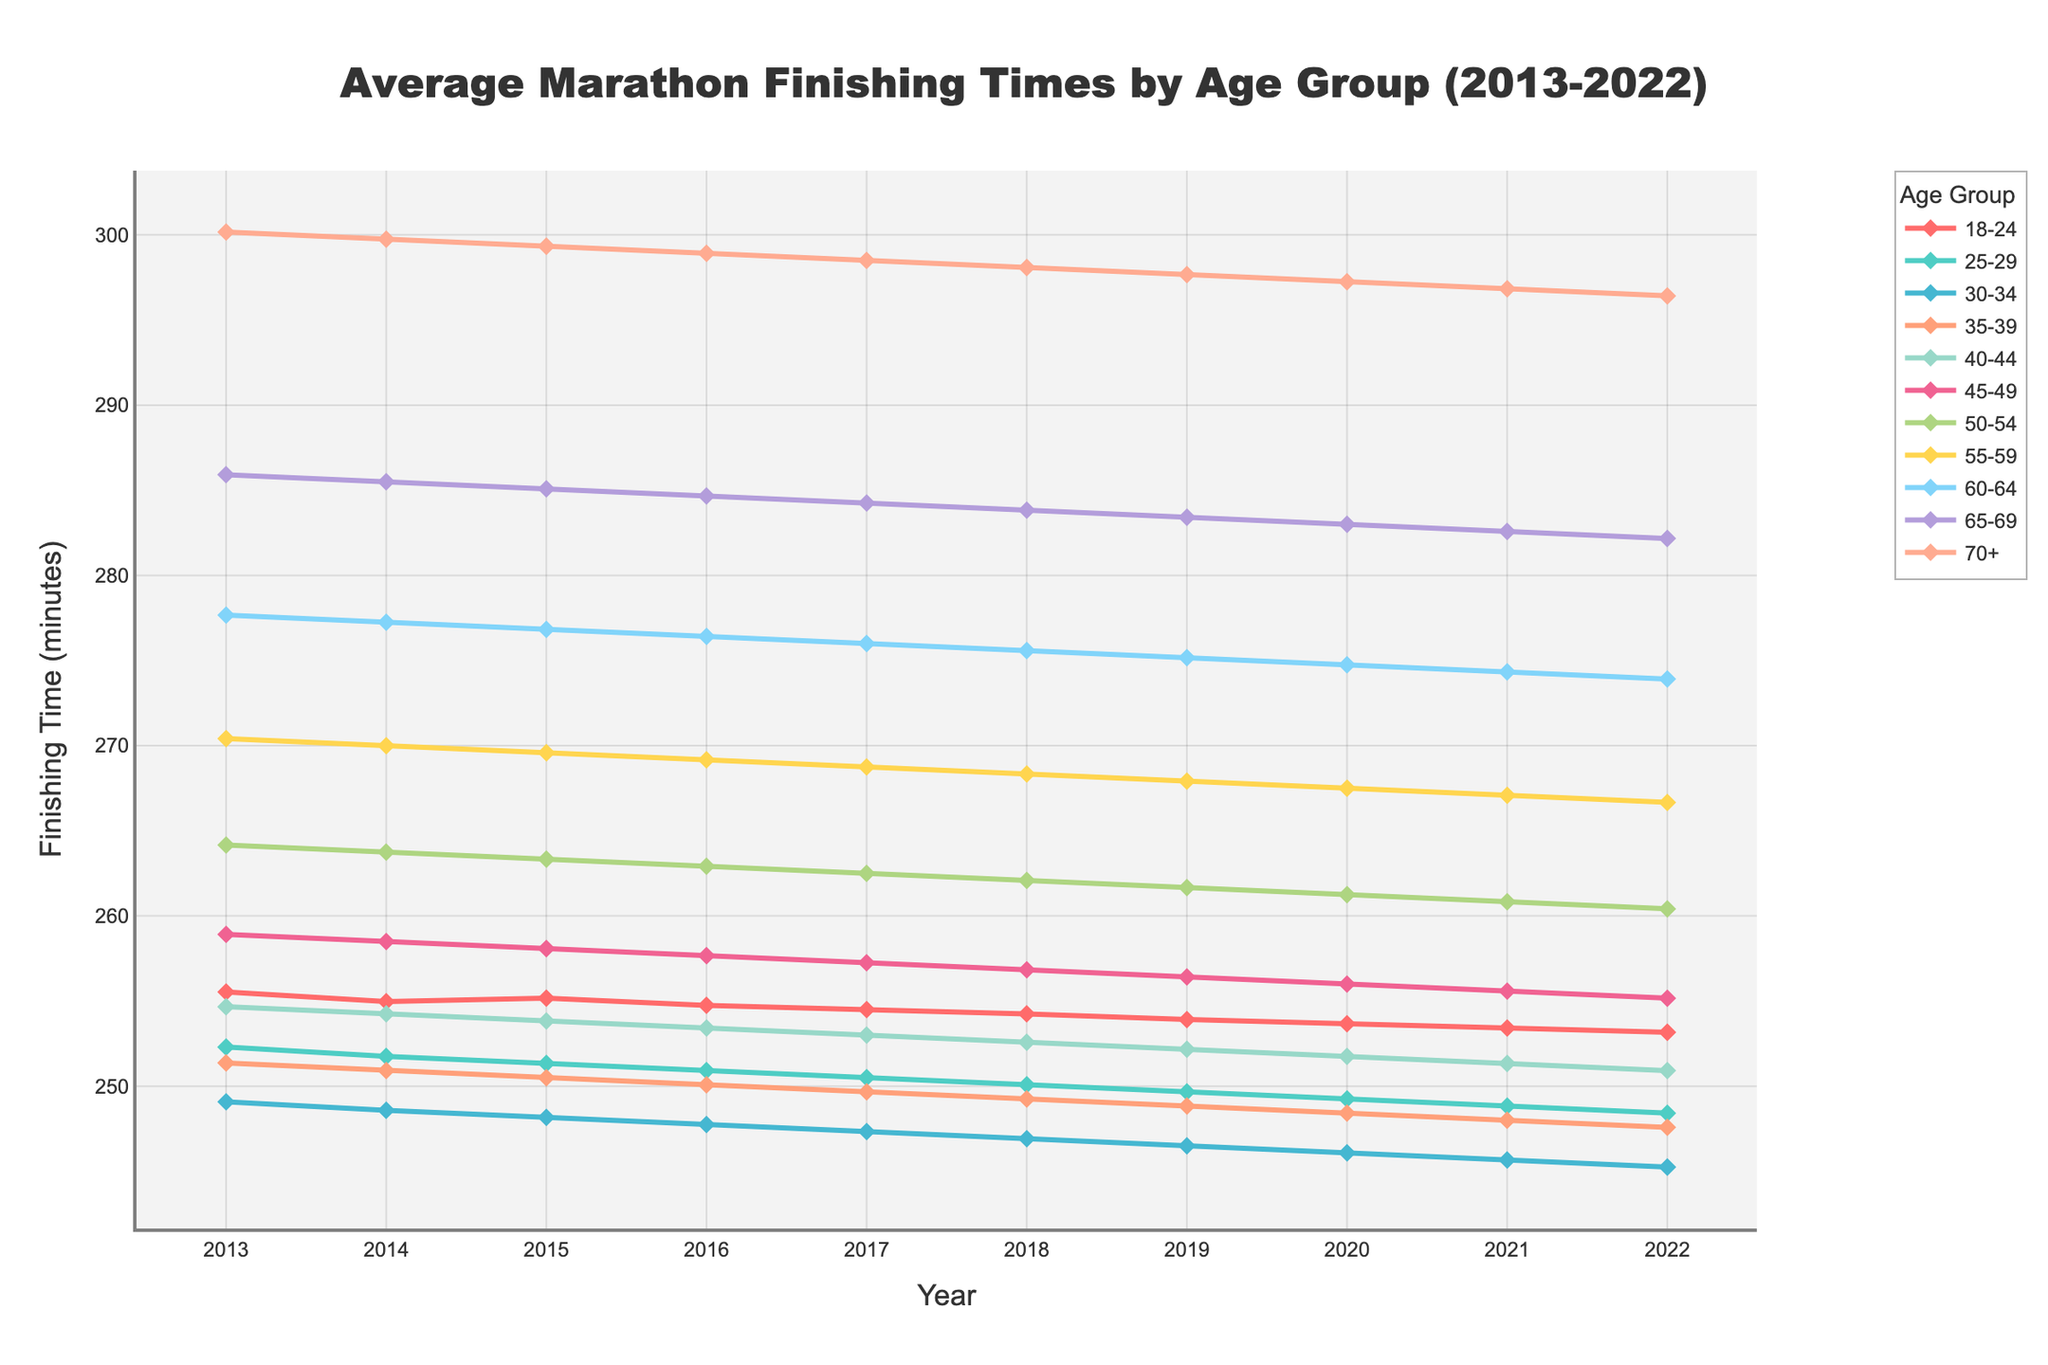What's the average finishing time for the 25-29 age group in 2020? The average finishing time for the 25-29 age group in 2020 can be seen by identifying the corresponding point on the line chart for that age group in 2020.
Answer: 4:09:15 How does the finishing time of the 30-34 age group in 2022 compare to the finishing time of the 18-24 age group in the same year? First, identify the finishing times for both age groups in 2022. The 30-34 age group finishes in 4:05:15 while the 18-24 age group finishes in 4:13:10. The 30-34 age group is faster.
Answer: The 30-34 age group is faster Which age group has the highest finishing time in 2015? By comparing the points on the line chart for all age groups in 2015, the 70+ age group has the highest finishing time of 4:59:20.
Answer: 70+ What is the overall trend for finishing times for the 55-59 age group from 2013 to 2022? Observing the line for the 55-59 age group, it shows a decreasing trend in finishing times from 4:30:25 in 2013 to 4:26:40 in 2022.
Answer: Decreasing trend Which age group improved the most in terms of finishing time from 2013 to 2022? Calculate the difference between the finishing times in 2013 and 2022 for each age group. The age group with the largest decrease shows the most improvement. The 25-29 age group improved by 4:12:18 - 4:08:25 = 3:53.
Answer: 25-29 What was the finishing time difference between the 45-49 and 50-54 age groups in 2017? Compare the finishing times for both age groups in 2017. The 45-49 age group finishes in 4:17:15 and the 50-54 age group finishes in 4:22:30. The difference is 4:22:30 - 4:17:15 = 5:15.
Answer: 5:15 Is there any age group with a constant finishing time trend over the years? Observing the chart, all age groups show a decreasing trend in finishing times, so none have a constant trend.
Answer: No Which age group had the most significant decrease in finishing time in 2016 compared to the previous year? Calculate the decrease in finishing times from 2015 to 2016 for each age group. The 55-59 age group had the most significant decrease from 4:29:35 to 4:29:10, a 25-second decrease.
Answer: 55-59 For the year 2022, rank the age groups from fastest to slowest average finishing time. List the finishing times for each age group in 2022: 30-34 (4:05:15), 35-39 (4:07:35), 25-29 (4:08:25), 40-44 (4:10:55), 18-24 (4:13:10), 45-49 (4:15:10), 50-54 (4:20:25), 55-59 (4:26:40), 60-64 (4:33:55), 65-69 (4:42:10), 70+ (4:56:25). Sort them.
Answer: 30-34, 35-39, 25-29, 40-44, 18-24, 45-49, 50-54, 55-59, 60-64, 65-69, 70+ Which age group has the smallest variation in average finishing times across the decade? Evaluate the variation in finishing times for each age group. The 30-34 age group shows the smallest variation, with finishing times varying only by about 4 minutes.
Answer: 30-34 